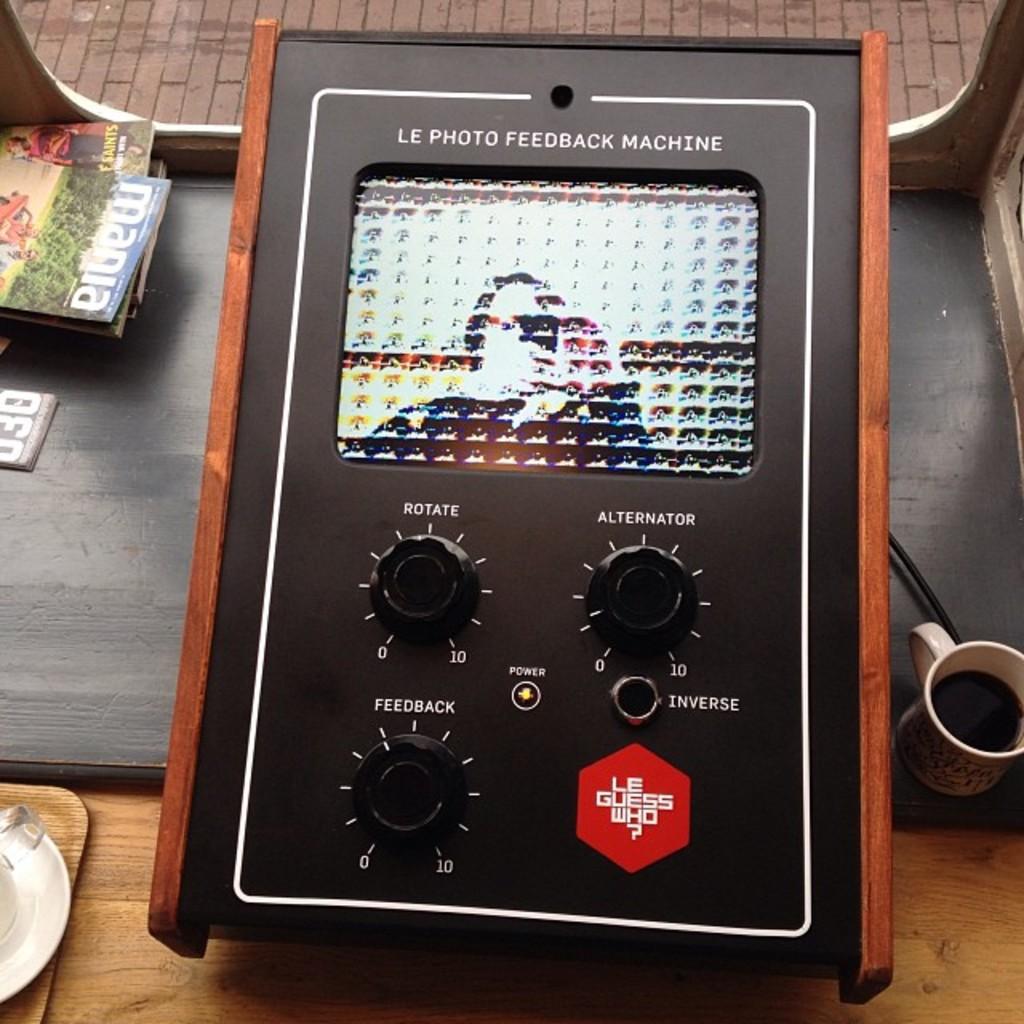What type of machine is this?
Your answer should be very brief. Le photo feedback machine. What does the knob on the left control?
Keep it short and to the point. Feedback. 